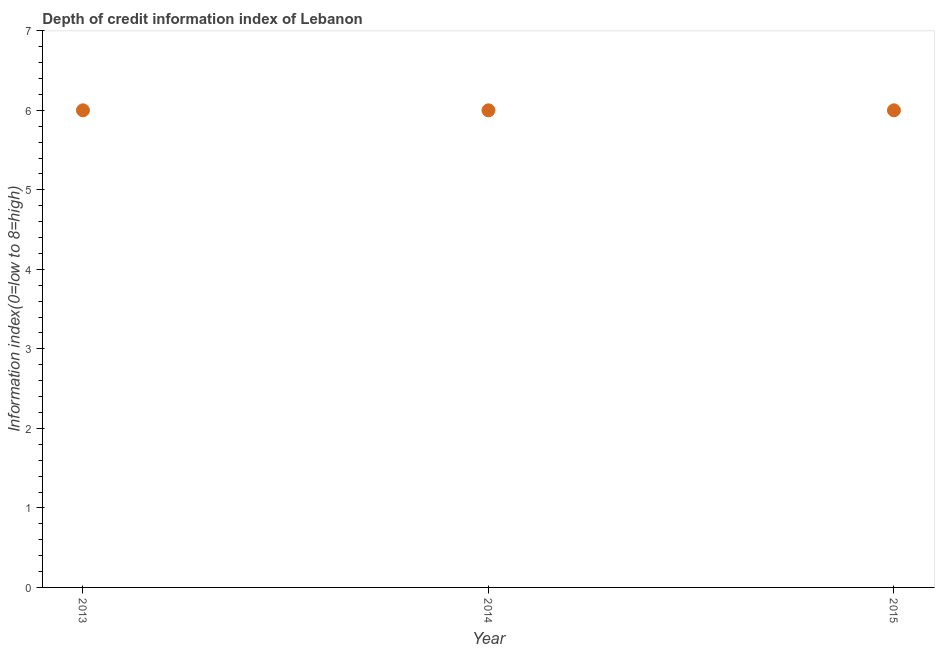What is the depth of credit information index in 2013?
Ensure brevity in your answer.  6. Across all years, what is the maximum depth of credit information index?
Provide a short and direct response. 6. Across all years, what is the minimum depth of credit information index?
Provide a succinct answer. 6. In which year was the depth of credit information index maximum?
Ensure brevity in your answer.  2013. What is the sum of the depth of credit information index?
Provide a succinct answer. 18. What is the difference between the depth of credit information index in 2013 and 2015?
Make the answer very short. 0. What is the average depth of credit information index per year?
Offer a very short reply. 6. What is the ratio of the depth of credit information index in 2014 to that in 2015?
Ensure brevity in your answer.  1. What is the difference between the highest and the lowest depth of credit information index?
Offer a terse response. 0. How many dotlines are there?
Your answer should be very brief. 1. How many years are there in the graph?
Give a very brief answer. 3. What is the difference between two consecutive major ticks on the Y-axis?
Offer a terse response. 1. Does the graph contain grids?
Offer a very short reply. No. What is the title of the graph?
Offer a very short reply. Depth of credit information index of Lebanon. What is the label or title of the Y-axis?
Offer a very short reply. Information index(0=low to 8=high). What is the Information index(0=low to 8=high) in 2013?
Ensure brevity in your answer.  6. What is the Information index(0=low to 8=high) in 2014?
Your answer should be compact. 6. What is the Information index(0=low to 8=high) in 2015?
Your answer should be very brief. 6. What is the difference between the Information index(0=low to 8=high) in 2013 and 2014?
Your answer should be very brief. 0. What is the difference between the Information index(0=low to 8=high) in 2013 and 2015?
Offer a very short reply. 0. What is the difference between the Information index(0=low to 8=high) in 2014 and 2015?
Provide a succinct answer. 0. What is the ratio of the Information index(0=low to 8=high) in 2014 to that in 2015?
Make the answer very short. 1. 